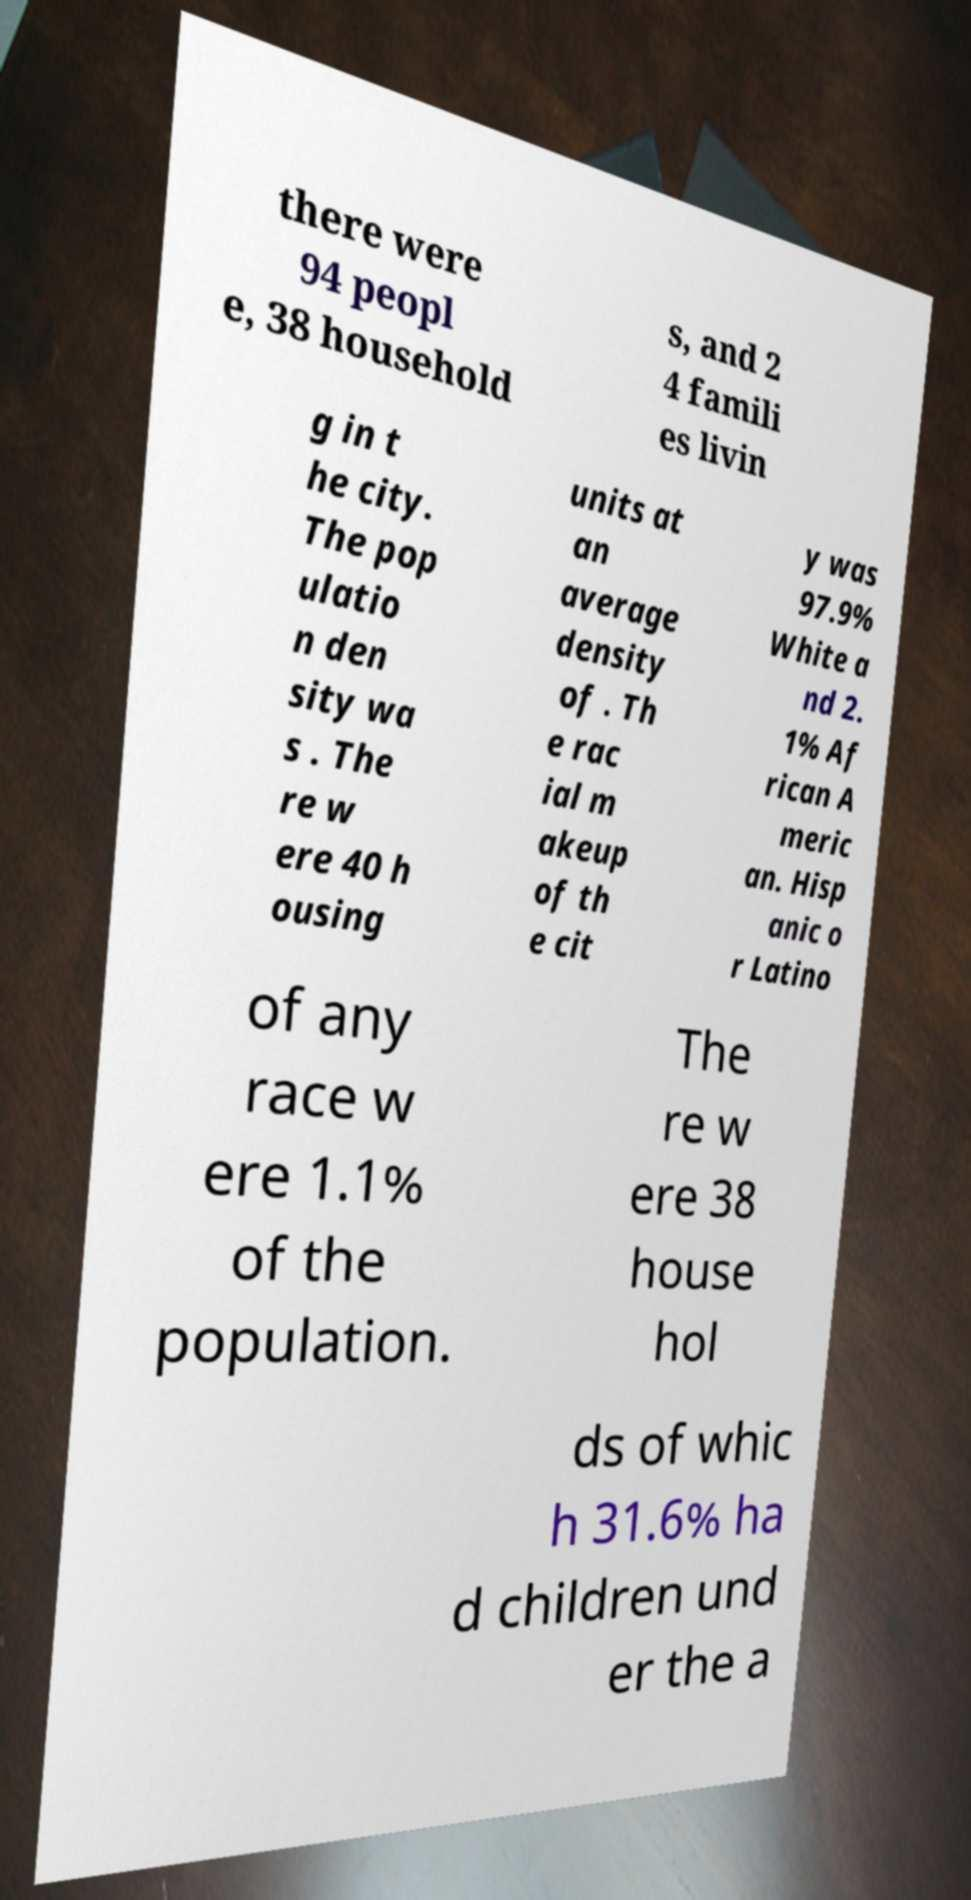Can you read and provide the text displayed in the image?This photo seems to have some interesting text. Can you extract and type it out for me? there were 94 peopl e, 38 household s, and 2 4 famili es livin g in t he city. The pop ulatio n den sity wa s . The re w ere 40 h ousing units at an average density of . Th e rac ial m akeup of th e cit y was 97.9% White a nd 2. 1% Af rican A meric an. Hisp anic o r Latino of any race w ere 1.1% of the population. The re w ere 38 house hol ds of whic h 31.6% ha d children und er the a 